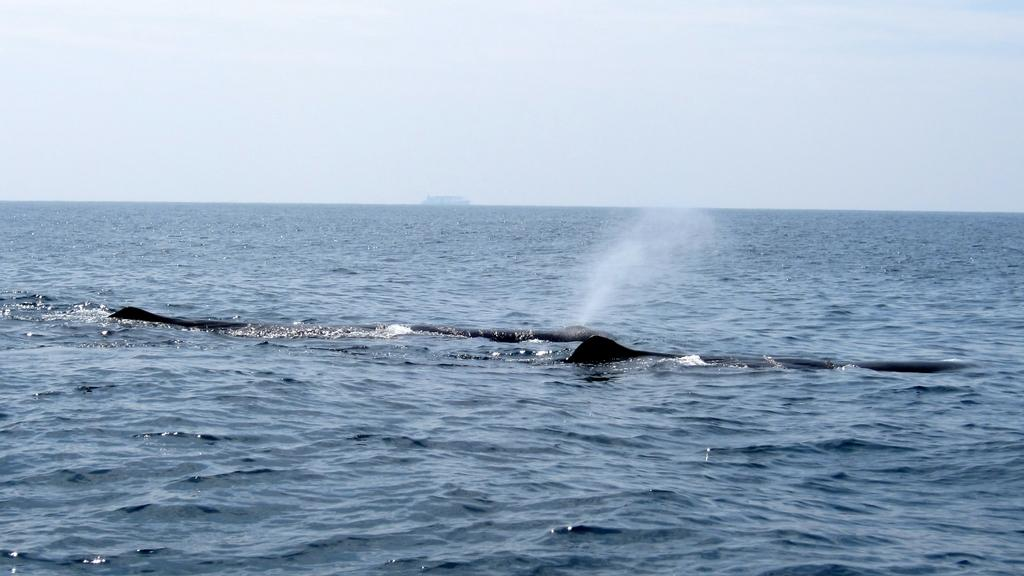What type of animals are in the image? There are aquatic animals in the image. Where are the aquatic animals situated in the image? The aquatic animals are in water. What is visible at the top of the image? The sky is visible at the top of the image. What type of trail can be seen in the image? There is no trail present in the image; it features aquatic animals in water. What kind of business is being conducted in the image? There is no business activity depicted in the image; it shows aquatic animals in their natural environment. 